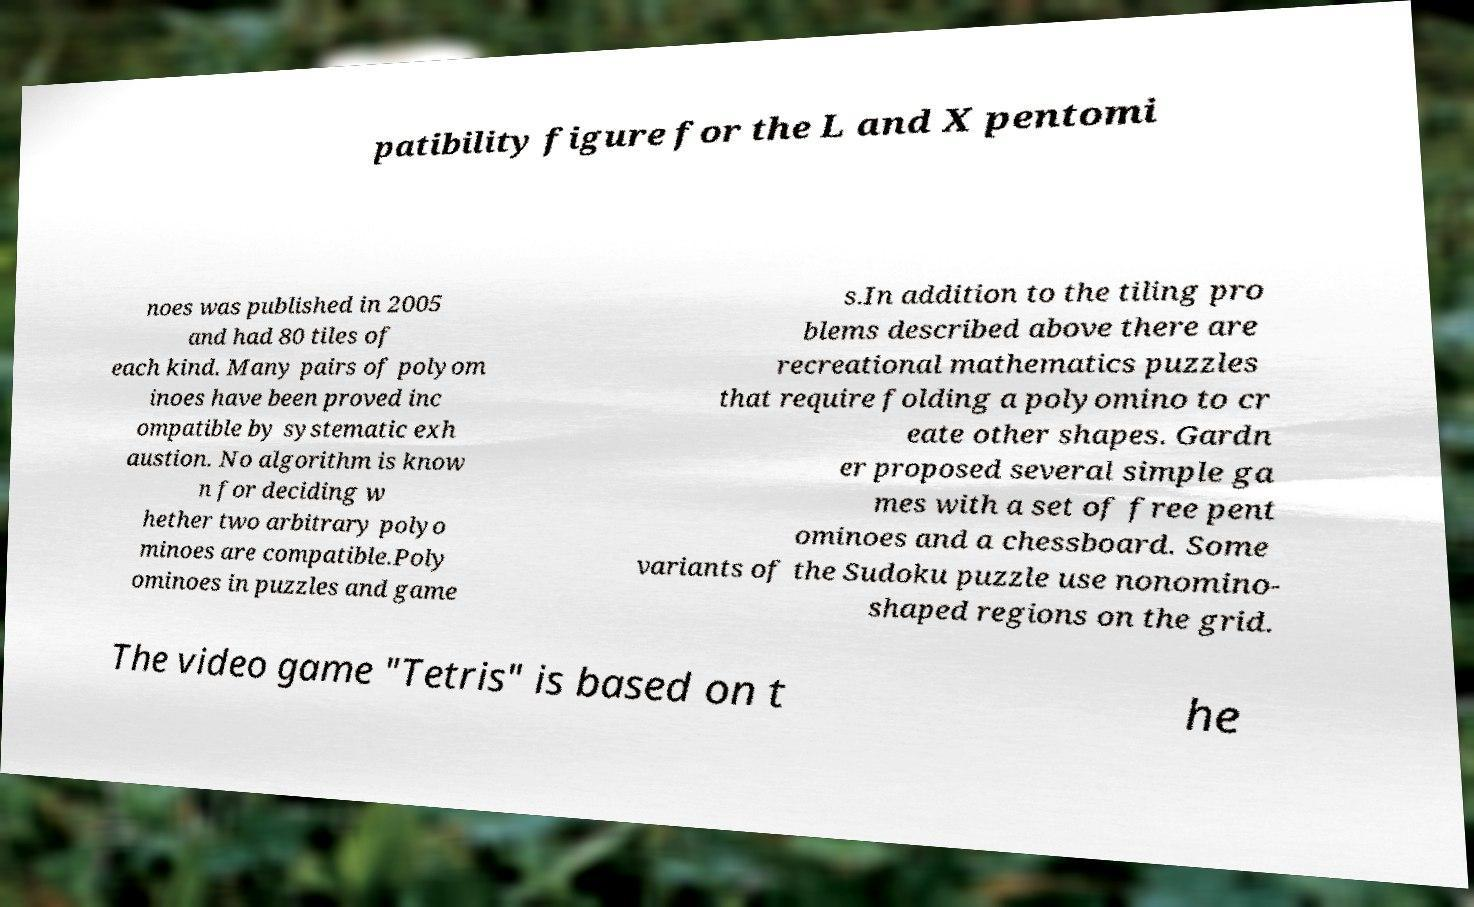Can you read and provide the text displayed in the image?This photo seems to have some interesting text. Can you extract and type it out for me? patibility figure for the L and X pentomi noes was published in 2005 and had 80 tiles of each kind. Many pairs of polyom inoes have been proved inc ompatible by systematic exh austion. No algorithm is know n for deciding w hether two arbitrary polyo minoes are compatible.Poly ominoes in puzzles and game s.In addition to the tiling pro blems described above there are recreational mathematics puzzles that require folding a polyomino to cr eate other shapes. Gardn er proposed several simple ga mes with a set of free pent ominoes and a chessboard. Some variants of the Sudoku puzzle use nonomino- shaped regions on the grid. The video game "Tetris" is based on t he 